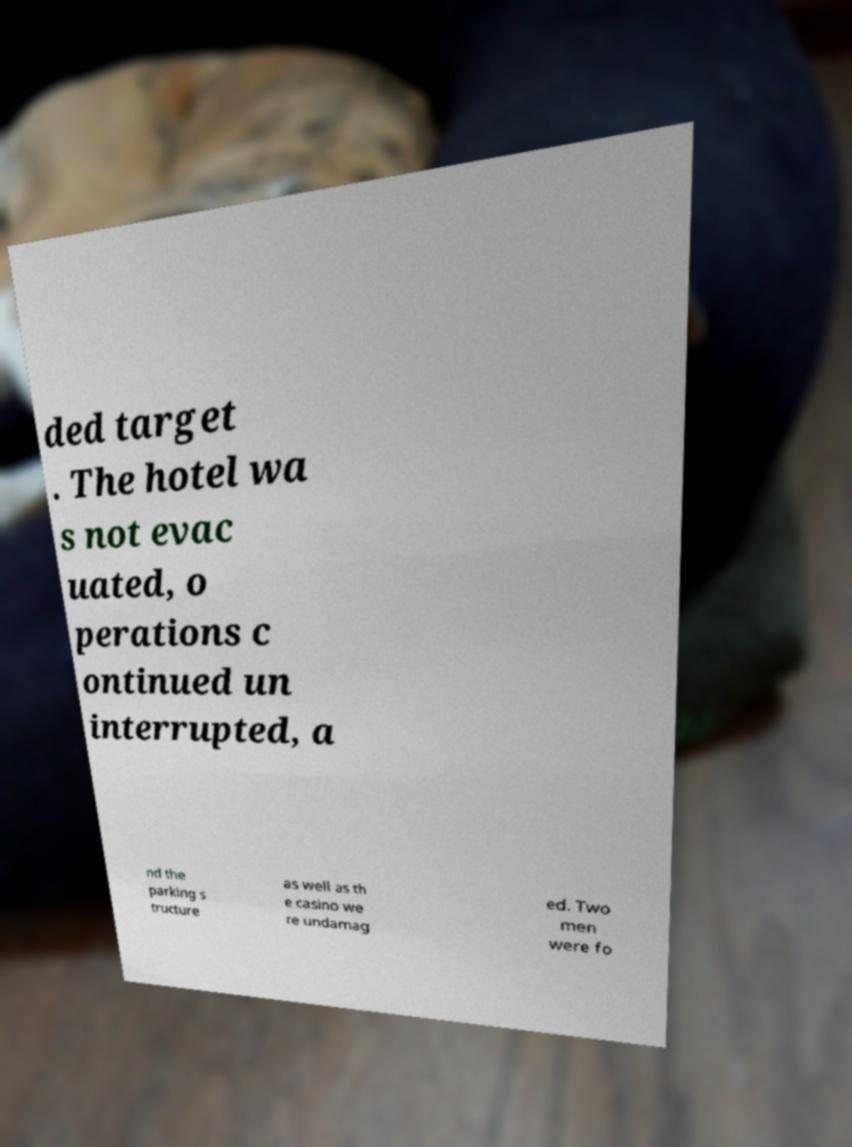Could you assist in decoding the text presented in this image and type it out clearly? ded target . The hotel wa s not evac uated, o perations c ontinued un interrupted, a nd the parking s tructure as well as th e casino we re undamag ed. Two men were fo 